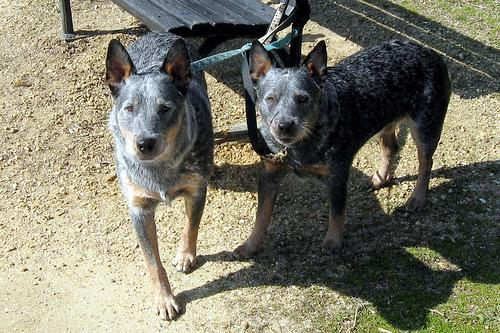What would most likely explain why these dogs look similar? Please explain your reasoning. family. The dogs may be related given the same breed and same geographical location. 